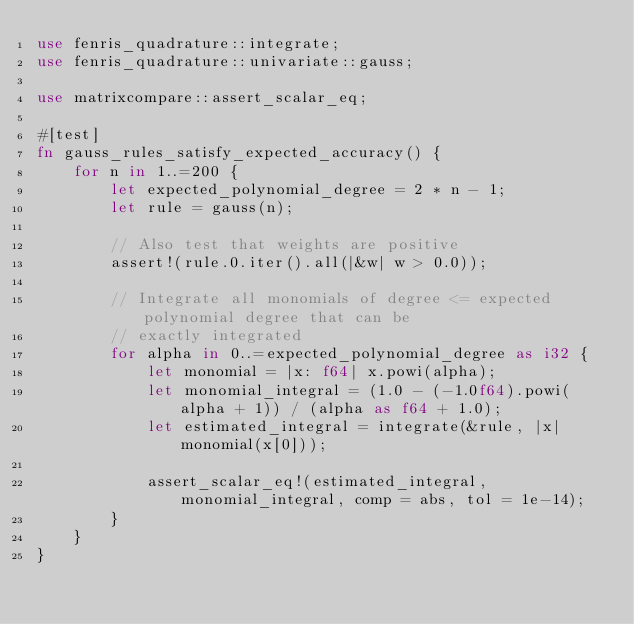<code> <loc_0><loc_0><loc_500><loc_500><_Rust_>use fenris_quadrature::integrate;
use fenris_quadrature::univariate::gauss;

use matrixcompare::assert_scalar_eq;

#[test]
fn gauss_rules_satisfy_expected_accuracy() {
    for n in 1..=200 {
        let expected_polynomial_degree = 2 * n - 1;
        let rule = gauss(n);

        // Also test that weights are positive
        assert!(rule.0.iter().all(|&w| w > 0.0));

        // Integrate all monomials of degree <= expected polynomial degree that can be
        // exactly integrated
        for alpha in 0..=expected_polynomial_degree as i32 {
            let monomial = |x: f64| x.powi(alpha);
            let monomial_integral = (1.0 - (-1.0f64).powi(alpha + 1)) / (alpha as f64 + 1.0);
            let estimated_integral = integrate(&rule, |x| monomial(x[0]));

            assert_scalar_eq!(estimated_integral, monomial_integral, comp = abs, tol = 1e-14);
        }
    }
}
</code> 